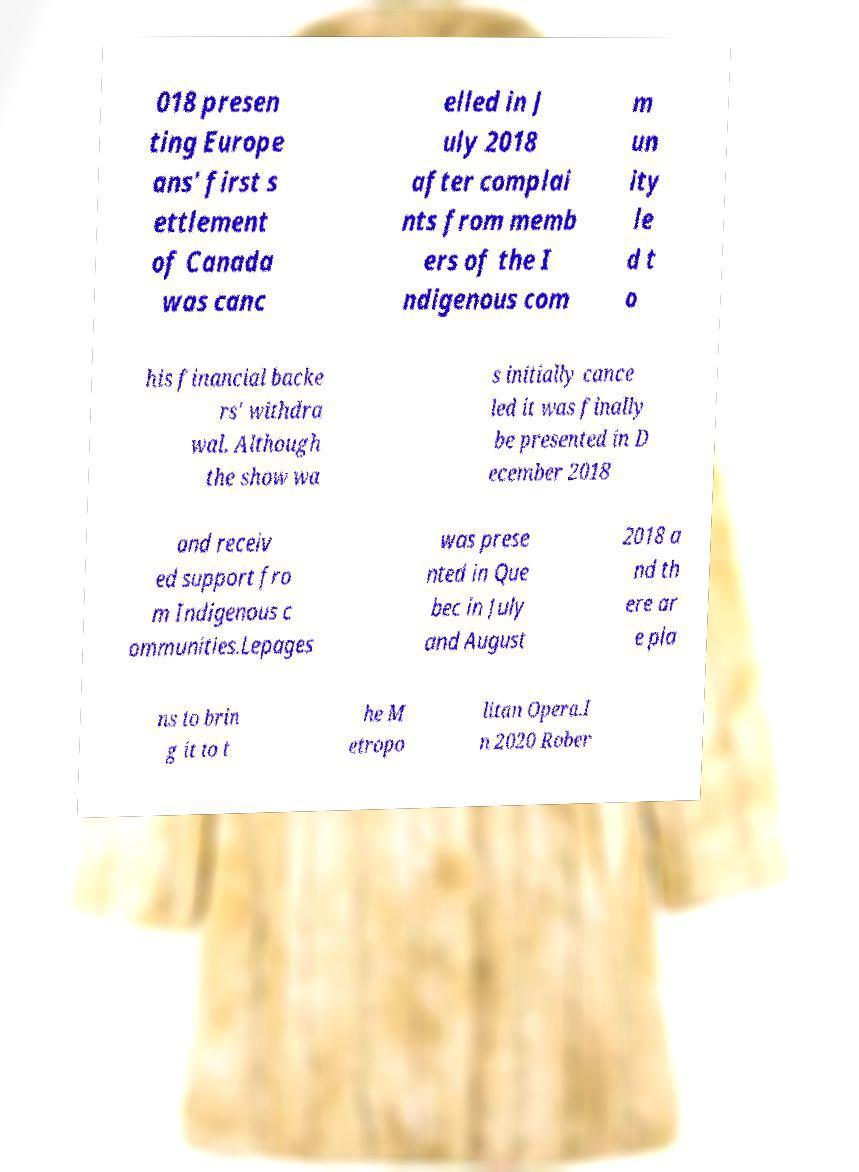I need the written content from this picture converted into text. Can you do that? 018 presen ting Europe ans' first s ettlement of Canada was canc elled in J uly 2018 after complai nts from memb ers of the I ndigenous com m un ity le d t o his financial backe rs' withdra wal. Although the show wa s initially cance led it was finally be presented in D ecember 2018 and receiv ed support fro m Indigenous c ommunities.Lepages was prese nted in Que bec in July and August 2018 a nd th ere ar e pla ns to brin g it to t he M etropo litan Opera.I n 2020 Rober 